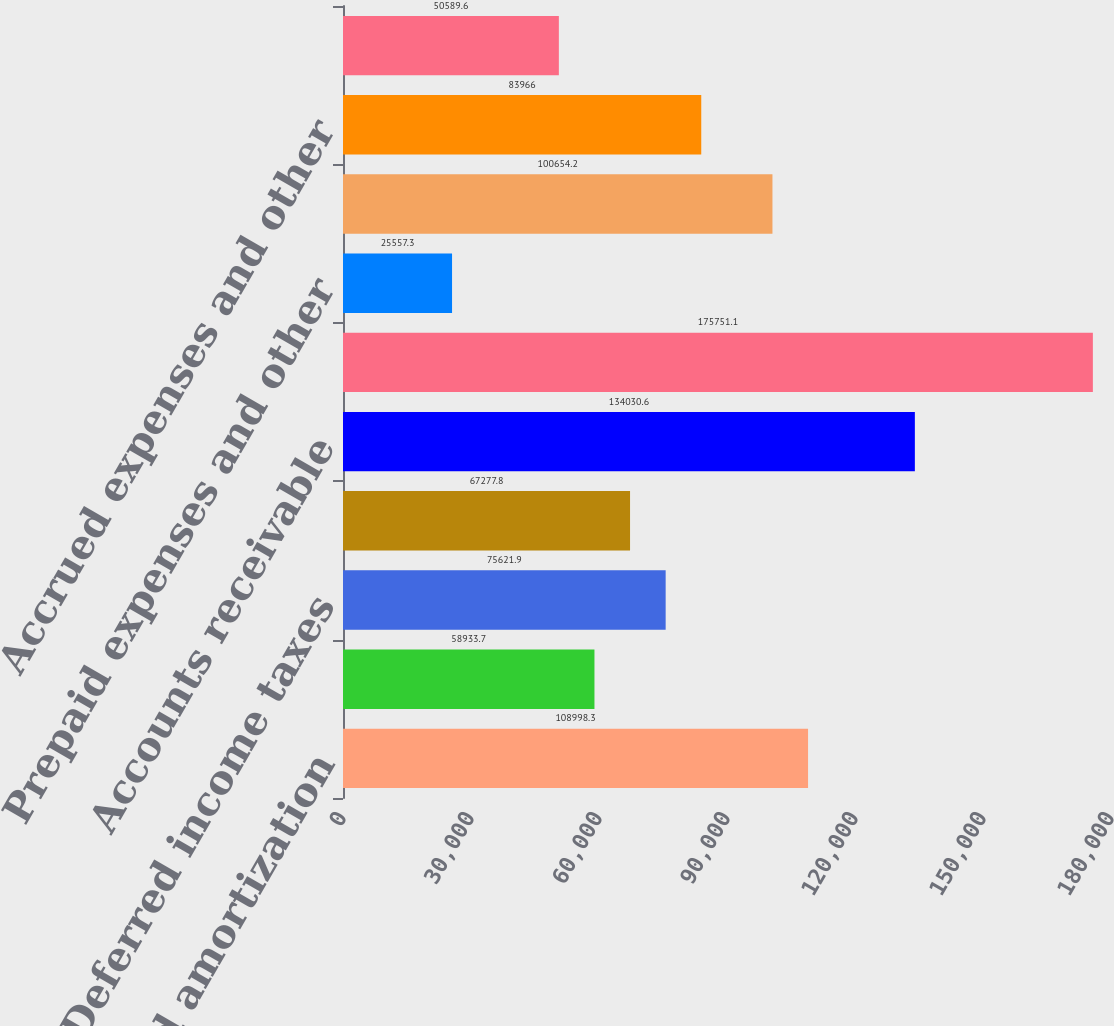<chart> <loc_0><loc_0><loc_500><loc_500><bar_chart><fcel>Depreciation and amortization<fcel>Stock-based compensation<fcel>Deferred income taxes<fcel>Changes in reserves for<fcel>Accounts receivable<fcel>Inventories<fcel>Prepaid expenses and other<fcel>Accounts payable<fcel>Accrued expenses and other<fcel>Income taxes payable and<nl><fcel>108998<fcel>58933.7<fcel>75621.9<fcel>67277.8<fcel>134031<fcel>175751<fcel>25557.3<fcel>100654<fcel>83966<fcel>50589.6<nl></chart> 